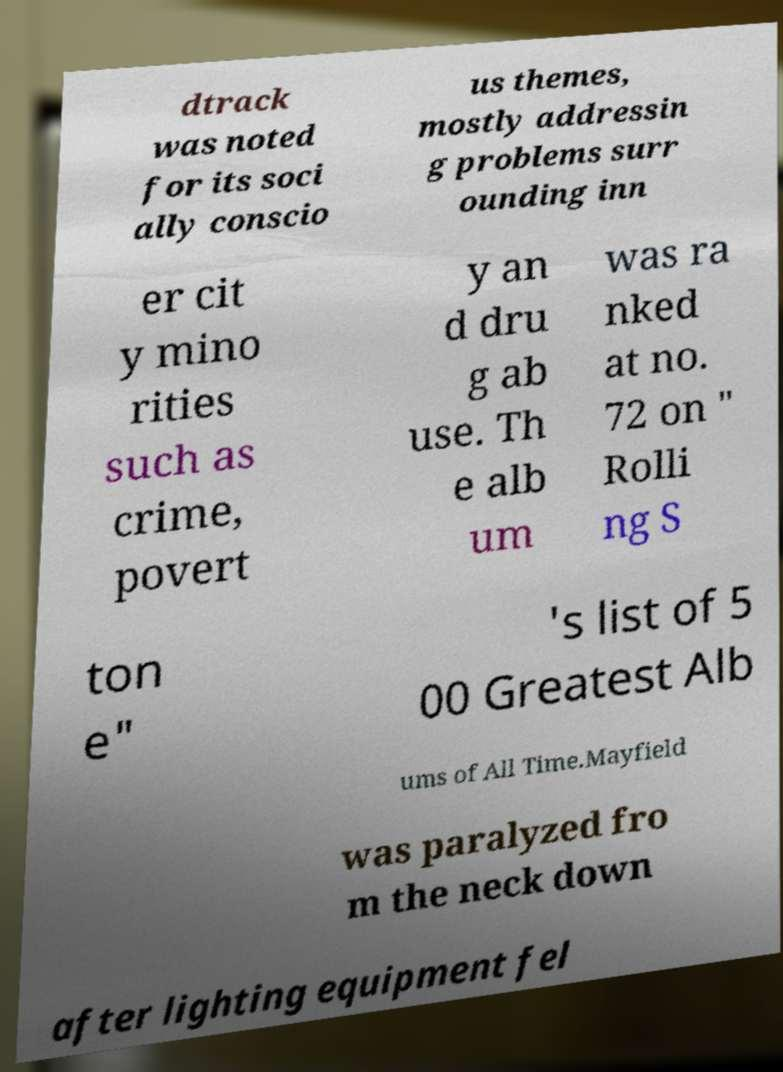Could you assist in decoding the text presented in this image and type it out clearly? dtrack was noted for its soci ally conscio us themes, mostly addressin g problems surr ounding inn er cit y mino rities such as crime, povert y an d dru g ab use. Th e alb um was ra nked at no. 72 on " Rolli ng S ton e" 's list of 5 00 Greatest Alb ums of All Time.Mayfield was paralyzed fro m the neck down after lighting equipment fel 